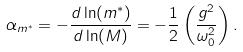<formula> <loc_0><loc_0><loc_500><loc_500>\alpha _ { m ^ { * } } = - \frac { d \ln ( m ^ { * } ) } { d \ln ( M ) } = - \frac { 1 } { 2 } \left ( \frac { g ^ { 2 } } { \omega _ { 0 } ^ { 2 } } \right ) .</formula> 